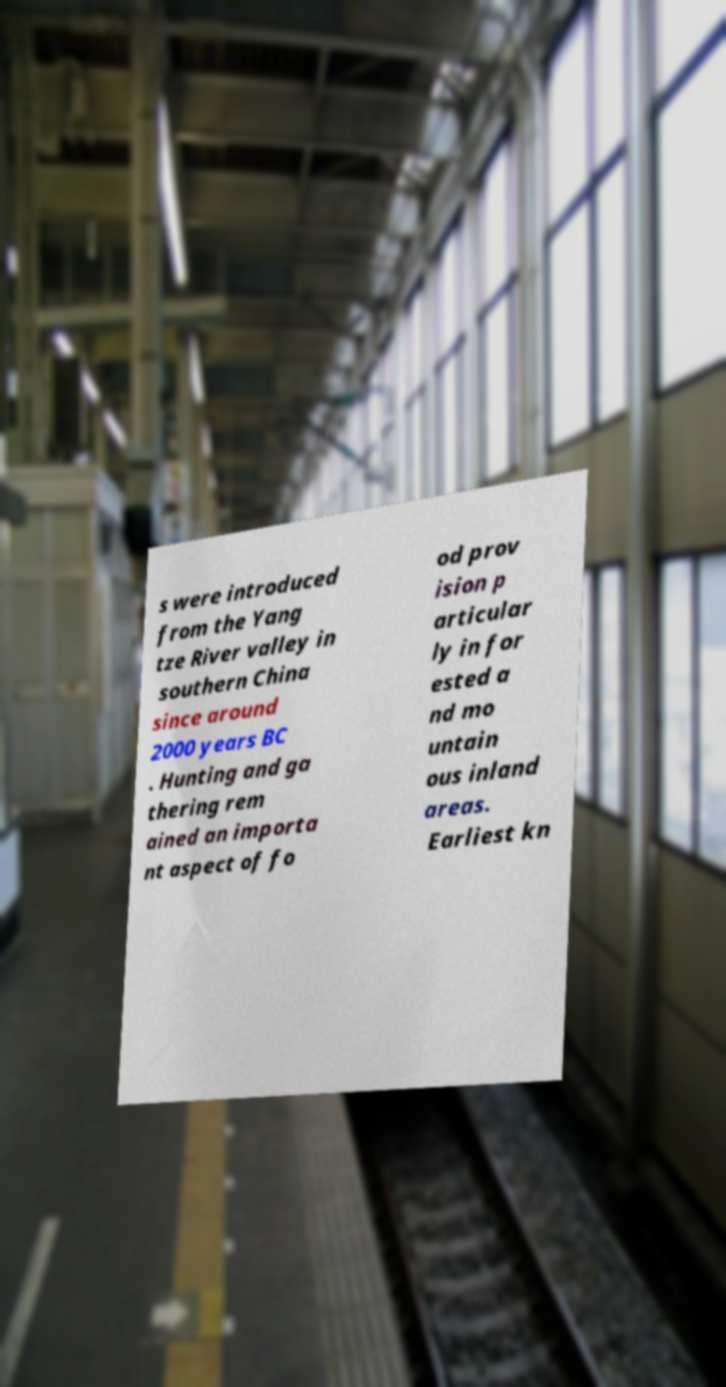Could you extract and type out the text from this image? s were introduced from the Yang tze River valley in southern China since around 2000 years BC . Hunting and ga thering rem ained an importa nt aspect of fo od prov ision p articular ly in for ested a nd mo untain ous inland areas. Earliest kn 